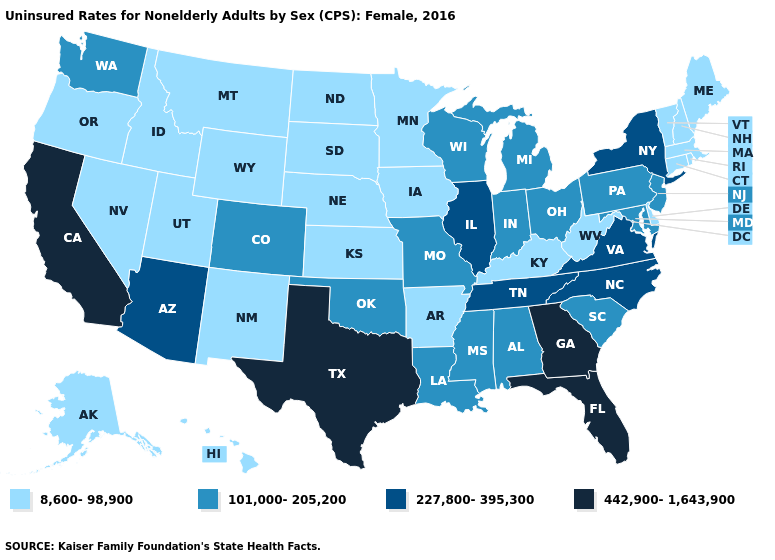Name the states that have a value in the range 8,600-98,900?
Quick response, please. Alaska, Arkansas, Connecticut, Delaware, Hawaii, Idaho, Iowa, Kansas, Kentucky, Maine, Massachusetts, Minnesota, Montana, Nebraska, Nevada, New Hampshire, New Mexico, North Dakota, Oregon, Rhode Island, South Dakota, Utah, Vermont, West Virginia, Wyoming. Name the states that have a value in the range 442,900-1,643,900?
Answer briefly. California, Florida, Georgia, Texas. Name the states that have a value in the range 8,600-98,900?
Be succinct. Alaska, Arkansas, Connecticut, Delaware, Hawaii, Idaho, Iowa, Kansas, Kentucky, Maine, Massachusetts, Minnesota, Montana, Nebraska, Nevada, New Hampshire, New Mexico, North Dakota, Oregon, Rhode Island, South Dakota, Utah, Vermont, West Virginia, Wyoming. Does Idaho have the same value as Iowa?
Keep it brief. Yes. Does Mississippi have the lowest value in the South?
Quick response, please. No. Does New Mexico have a lower value than Louisiana?
Be succinct. Yes. Name the states that have a value in the range 442,900-1,643,900?
Quick response, please. California, Florida, Georgia, Texas. Which states have the highest value in the USA?
Answer briefly. California, Florida, Georgia, Texas. Name the states that have a value in the range 227,800-395,300?
Write a very short answer. Arizona, Illinois, New York, North Carolina, Tennessee, Virginia. What is the value of Tennessee?
Write a very short answer. 227,800-395,300. Does Florida have the highest value in the USA?
Keep it brief. Yes. Which states hav the highest value in the MidWest?
Quick response, please. Illinois. Name the states that have a value in the range 227,800-395,300?
Write a very short answer. Arizona, Illinois, New York, North Carolina, Tennessee, Virginia. What is the highest value in the West ?
Write a very short answer. 442,900-1,643,900. What is the value of Minnesota?
Concise answer only. 8,600-98,900. 